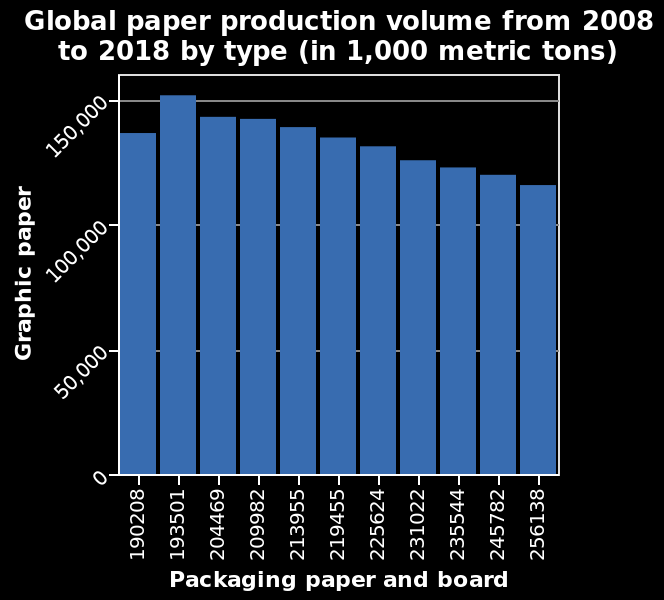<image>
What is the range of the y-axis on the bar graph? The range of the y-axis on the bar graph is from 0 to 150,000. Has production been consistently declining since 2008? No, production increased to above 150,000 in 2009 but has been steadily decreasing every year since then. 